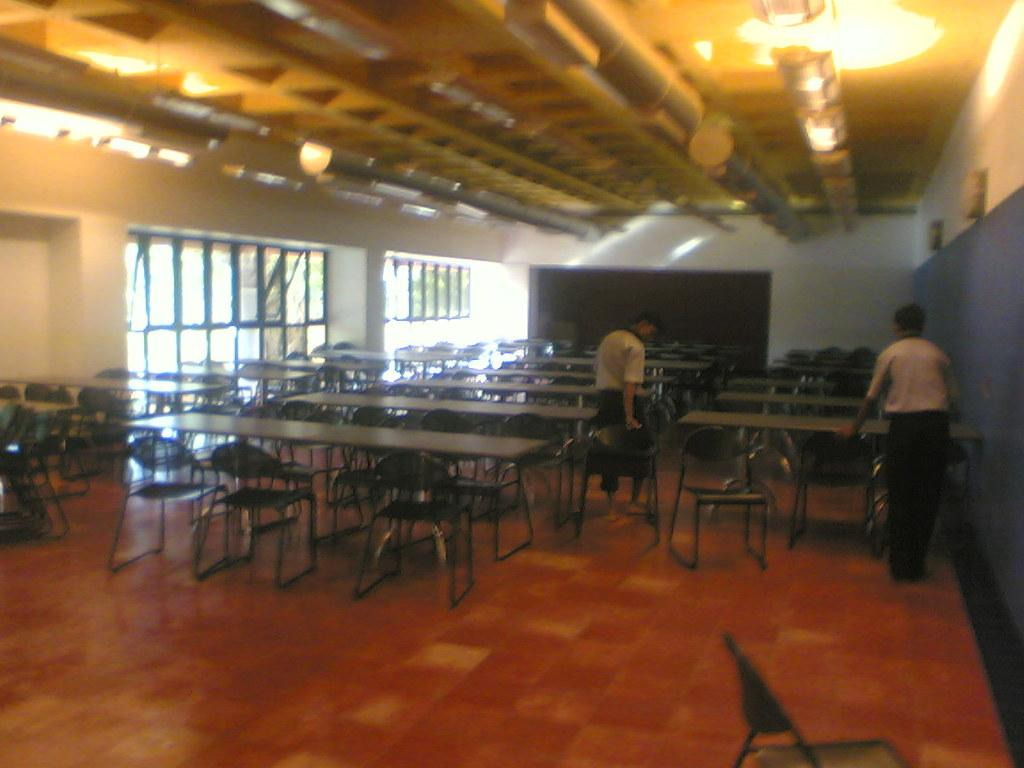What type of furniture is present in the image? There are chairs and tables in the image. How many boys are in the image? There are 2 boys in the image. What can be seen in the background of the image? There are windows, a wall, and a board in the background of the image. What type of frame is holding the ducks in the image? There are no ducks present in the image, so there is no frame holding them. 